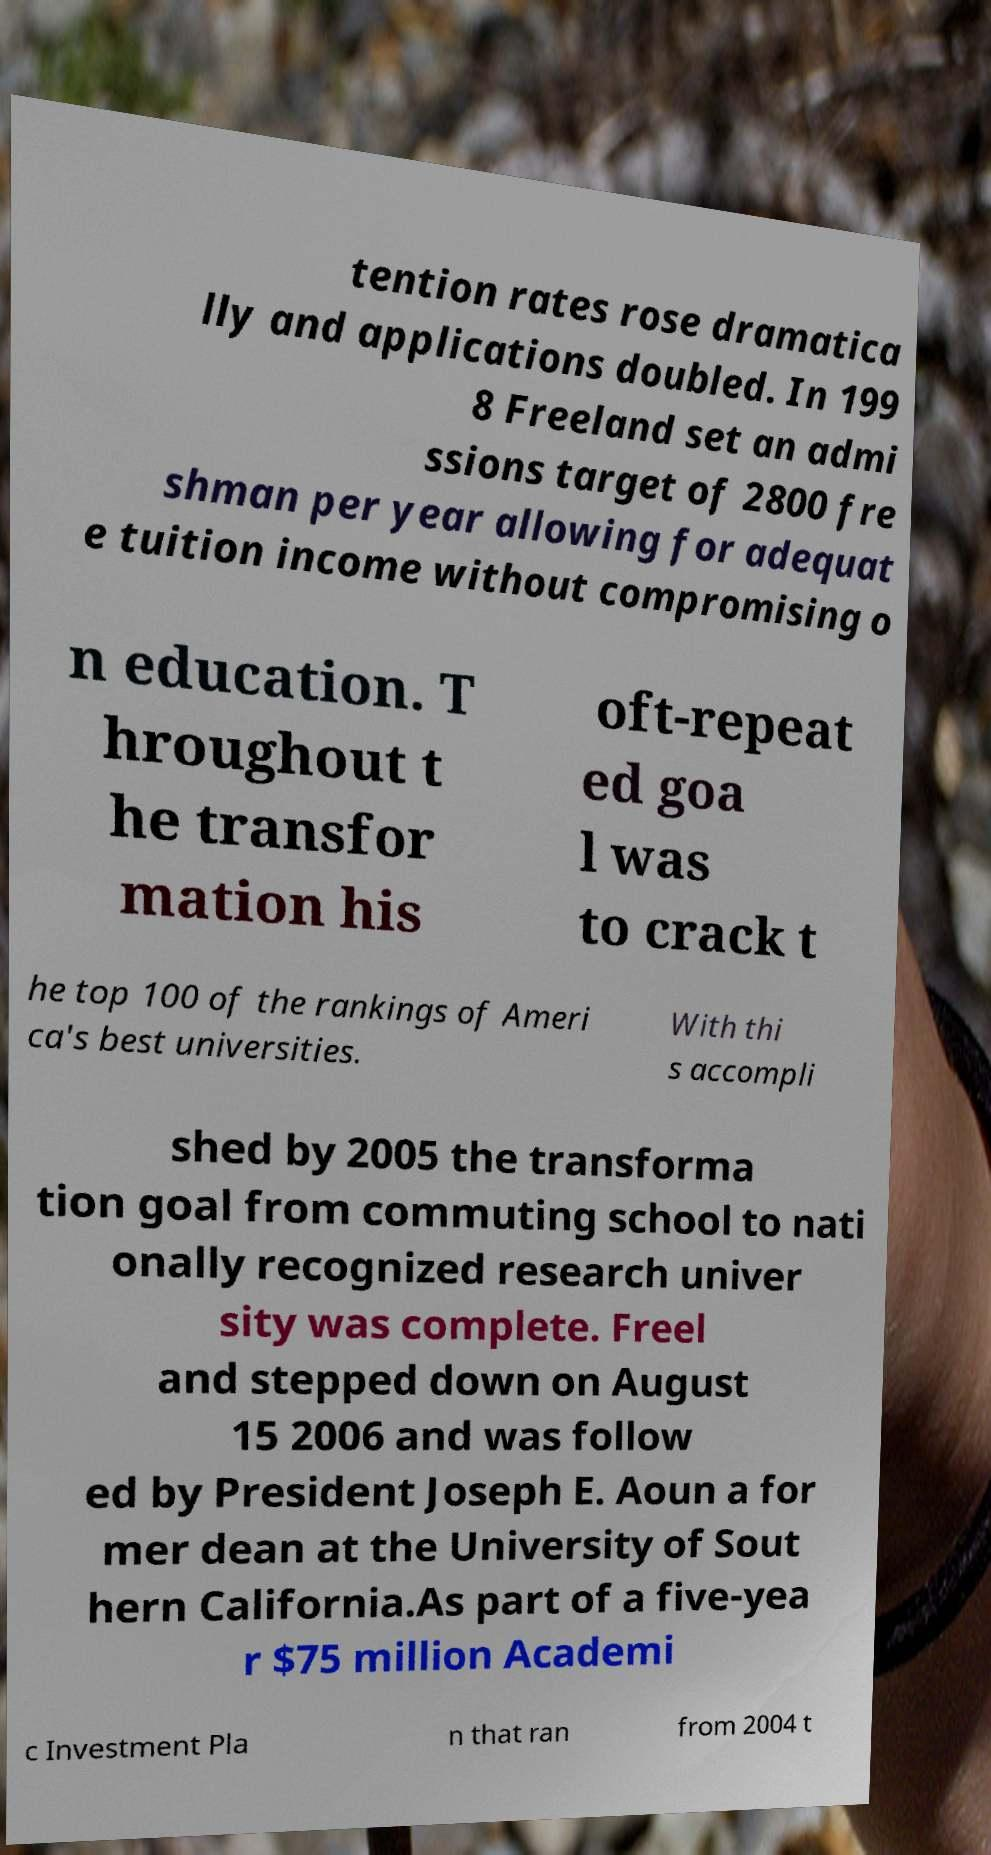Please read and relay the text visible in this image. What does it say? tention rates rose dramatica lly and applications doubled. In 199 8 Freeland set an admi ssions target of 2800 fre shman per year allowing for adequat e tuition income without compromising o n education. T hroughout t he transfor mation his oft-repeat ed goa l was to crack t he top 100 of the rankings of Ameri ca's best universities. With thi s accompli shed by 2005 the transforma tion goal from commuting school to nati onally recognized research univer sity was complete. Freel and stepped down on August 15 2006 and was follow ed by President Joseph E. Aoun a for mer dean at the University of Sout hern California.As part of a five-yea r $75 million Academi c Investment Pla n that ran from 2004 t 